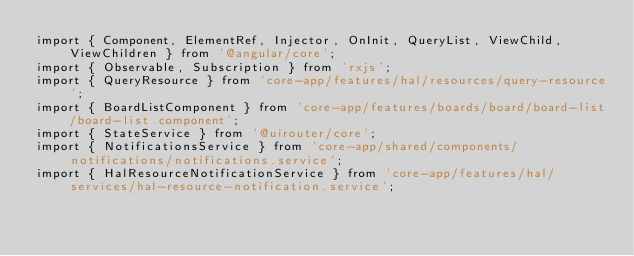<code> <loc_0><loc_0><loc_500><loc_500><_TypeScript_>import { Component, ElementRef, Injector, OnInit, QueryList, ViewChild, ViewChildren } from '@angular/core';
import { Observable, Subscription } from 'rxjs';
import { QueryResource } from 'core-app/features/hal/resources/query-resource';
import { BoardListComponent } from 'core-app/features/boards/board/board-list/board-list.component';
import { StateService } from '@uirouter/core';
import { NotificationsService } from 'core-app/shared/components/notifications/notifications.service';
import { HalResourceNotificationService } from 'core-app/features/hal/services/hal-resource-notification.service';</code> 